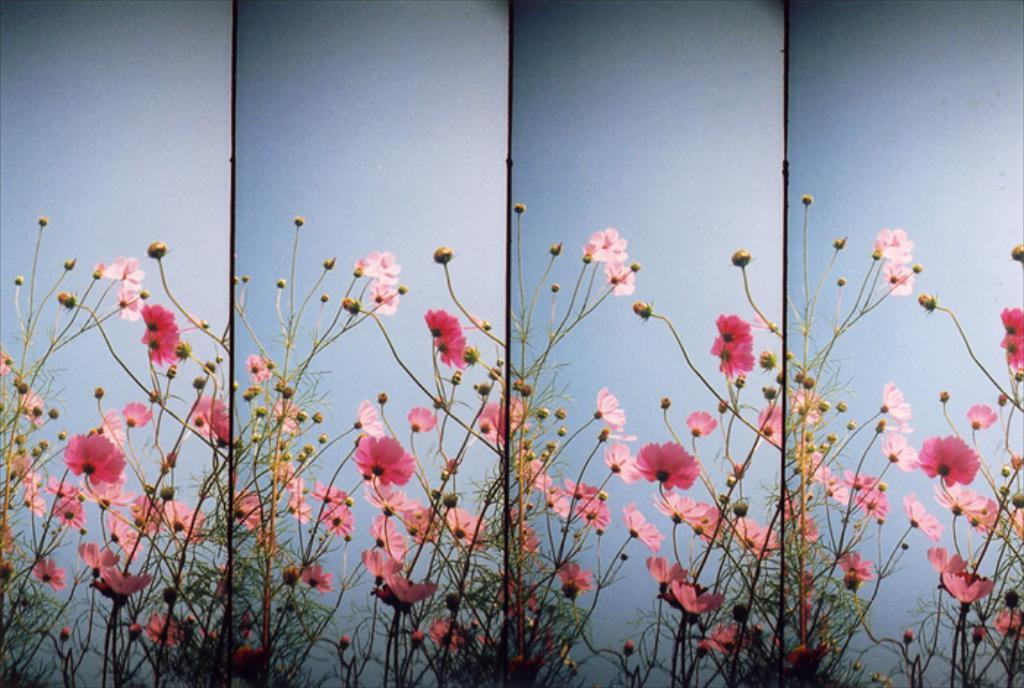What type of plant is in the image? The image contains a plant with flowers and buds. What can be observed on the plant besides the flowers and buds? The plant has branches. What color is the background of the image? The background of the image is blue. What type of apparel is the plant wearing in the image? Plants do not wear apparel, so this question cannot be answered. 